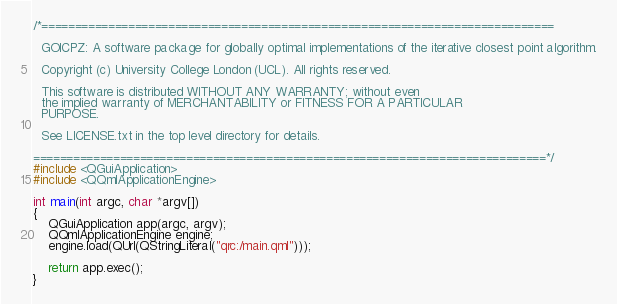Convert code to text. <code><loc_0><loc_0><loc_500><loc_500><_C++_>/*=============================================================================

  GOICPZ: A software package for globally optimal implementations of the iterative closest point algorithm.

  Copyright (c) University College London (UCL). All rights reserved.

  This software is distributed WITHOUT ANY WARRANTY; without even
  the implied warranty of MERCHANTABILITY or FITNESS FOR A PARTICULAR
  PURPOSE.

  See LICENSE.txt in the top level directory for details.

=============================================================================*/
#include <QGuiApplication>
#include <QQmlApplicationEngine>

int main(int argc, char *argv[])
{
    QGuiApplication app(argc, argv);
    QQmlApplicationEngine engine;
    engine.load(QUrl(QStringLiteral("qrc:/main.qml")));
	    
    return app.exec();
}

</code> 